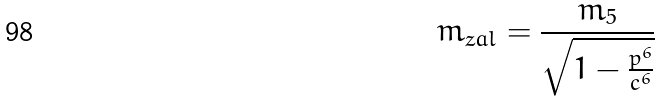Convert formula to latex. <formula><loc_0><loc_0><loc_500><loc_500>m _ { z a l } = \frac { m _ { 5 } } { \sqrt { 1 - \frac { p ^ { 6 } } { c ^ { 6 } } } }</formula> 